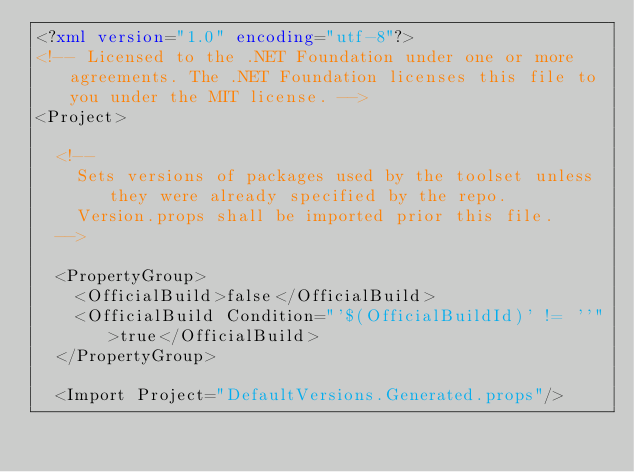<code> <loc_0><loc_0><loc_500><loc_500><_XML_><?xml version="1.0" encoding="utf-8"?>
<!-- Licensed to the .NET Foundation under one or more agreements. The .NET Foundation licenses this file to you under the MIT license. -->
<Project>

  <!--
    Sets versions of packages used by the toolset unless they were already specified by the repo.
    Version.props shall be imported prior this file.
  -->

  <PropertyGroup>
    <OfficialBuild>false</OfficialBuild>
    <OfficialBuild Condition="'$(OfficialBuildId)' != ''">true</OfficialBuild>
  </PropertyGroup>

  <Import Project="DefaultVersions.Generated.props"/></code> 